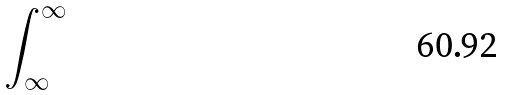<formula> <loc_0><loc_0><loc_500><loc_500>\int _ { \infty } ^ { \infty }</formula> 